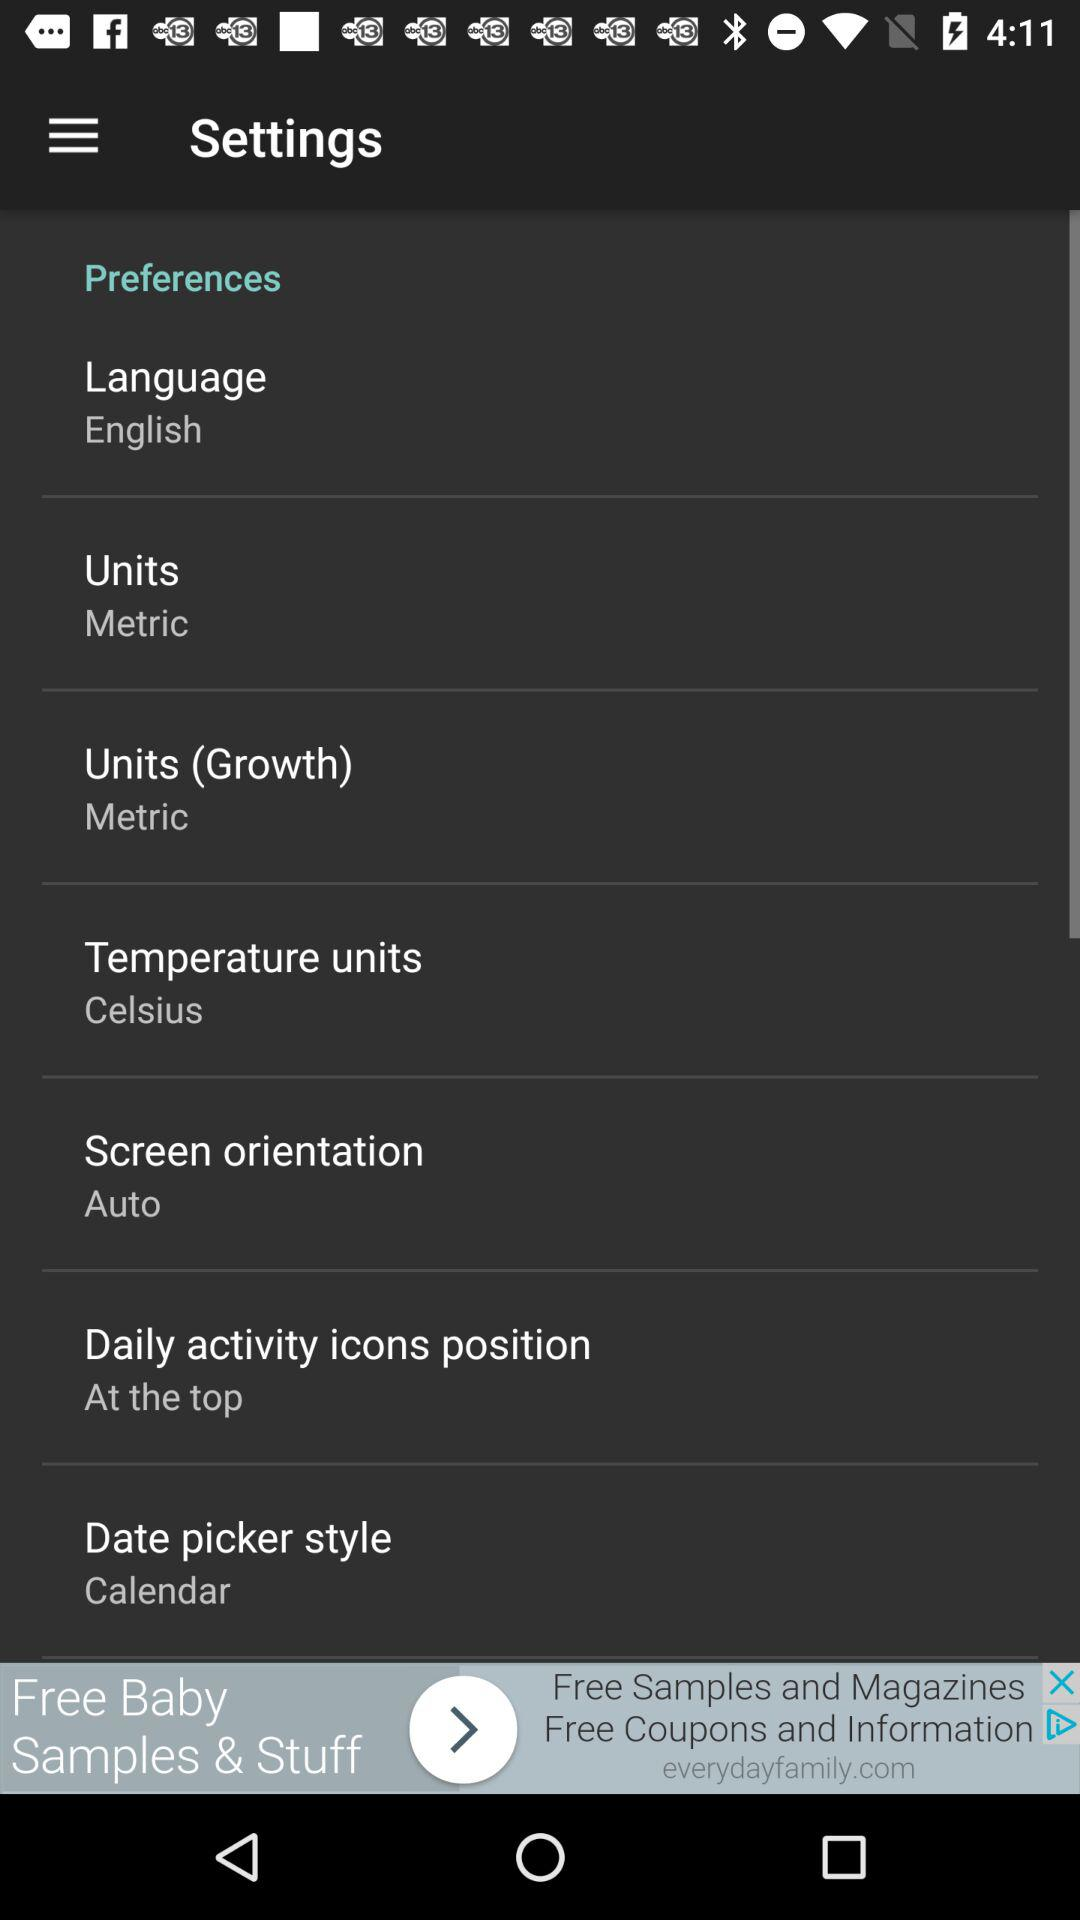What is the value of the "Temperature units"? The value of "Temperature units" is "Celsius". 